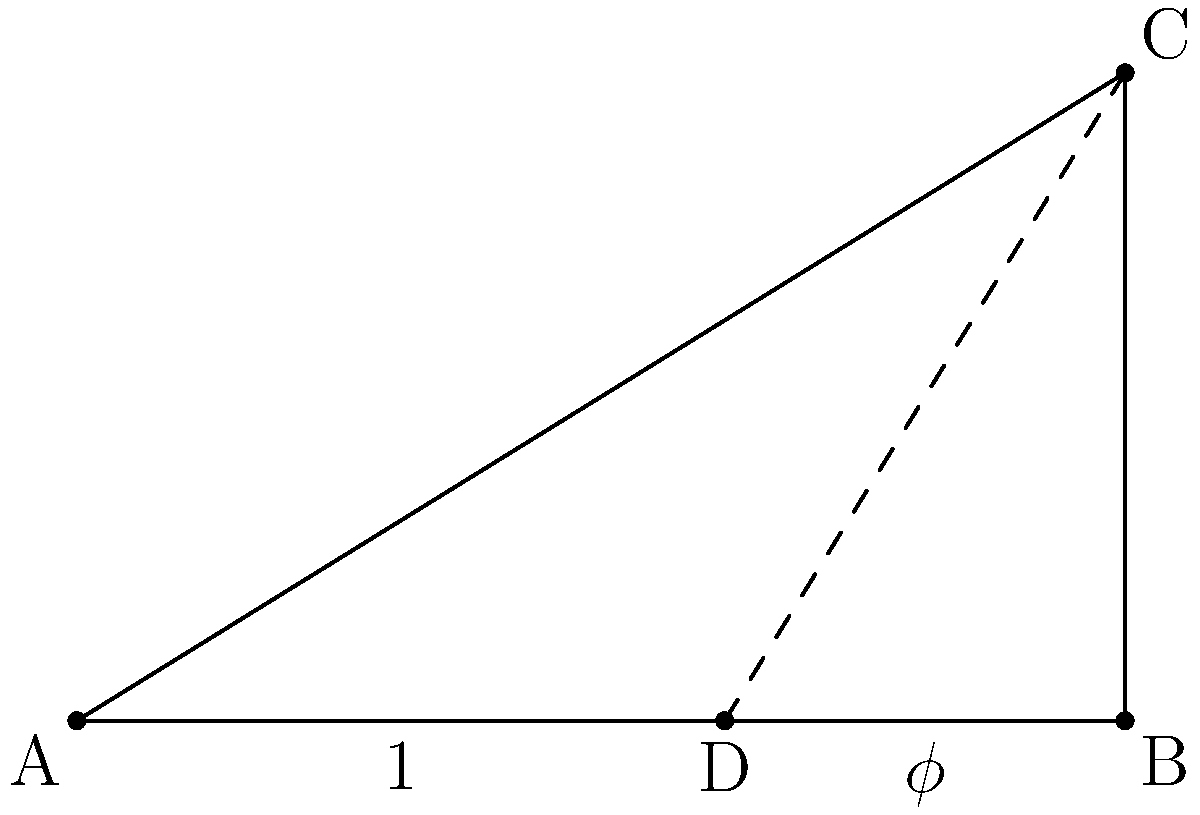In the given architectural sketch inspired by the golden ratio, triangle ABC represents a building facade. If the length of AB is 10 units and point D divides AB according to the golden ratio, what is the length of DC to the nearest hundredth? To solve this problem, we'll follow these steps:

1) The golden ratio, denoted by $\phi$, is approximately 1.618.

2) In the golden ratio, the whole is to the larger part as the larger part is to the smaller part. 
   If AB = 10, then:
   AD : DB = AB : AD
   
3) We can find AD:
   $\frac{AD}{10-AD} = \frac{10}{AD}$
   $AD^2 = 10(10-AD)$
   $AD^2 = 100 - 10AD$
   $AD^2 + 10AD - 100 = 0$
   
   Solving this quadratic equation:
   $AD = \frac{10}{\phi} \approx 6.18$ units

4) DB = 10 - 6.18 = 3.82 units

5) Now, we need to find DC. Triangle ABC is similar to triangle DBC.

6) In similar triangles, the ratio of corresponding sides is constant:
   $\frac{DC}{AB} = \frac{DB}{AB}$

7) We can write:
   $\frac{DC}{10} = \frac{3.82}{10}$

8) Solving for DC:
   $DC = 3.82$ units

Therefore, the length of DC is approximately 3.82 units.
Answer: 3.82 units 